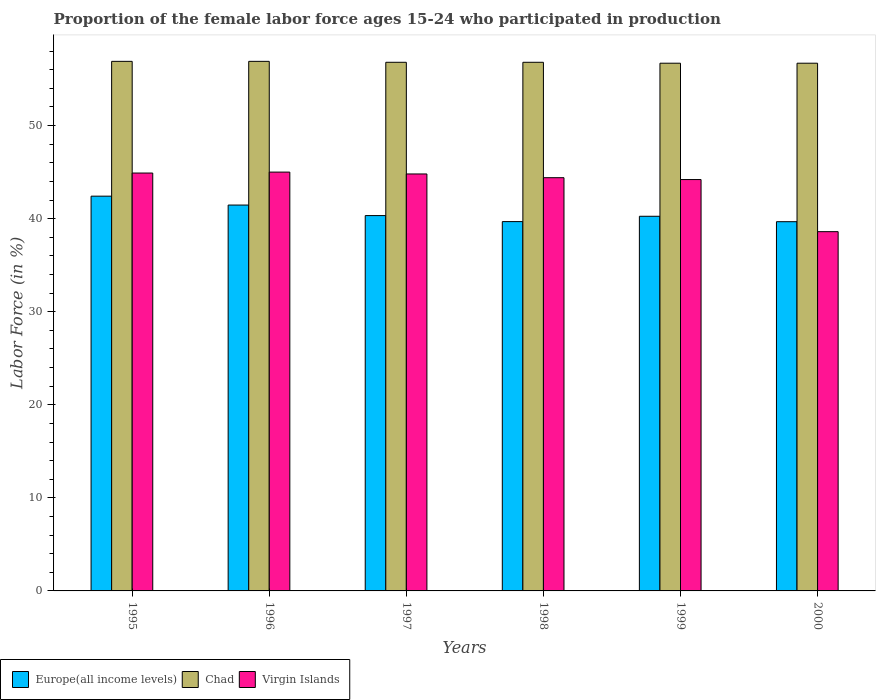How many groups of bars are there?
Provide a short and direct response. 6. Are the number of bars on each tick of the X-axis equal?
Give a very brief answer. Yes. What is the label of the 2nd group of bars from the left?
Your answer should be very brief. 1996. What is the proportion of the female labor force who participated in production in Virgin Islands in 1997?
Give a very brief answer. 44.8. Across all years, what is the maximum proportion of the female labor force who participated in production in Chad?
Your answer should be compact. 56.9. Across all years, what is the minimum proportion of the female labor force who participated in production in Virgin Islands?
Provide a succinct answer. 38.6. In which year was the proportion of the female labor force who participated in production in Virgin Islands minimum?
Keep it short and to the point. 2000. What is the total proportion of the female labor force who participated in production in Europe(all income levels) in the graph?
Provide a succinct answer. 243.81. What is the difference between the proportion of the female labor force who participated in production in Chad in 1997 and that in 1998?
Provide a short and direct response. 0. What is the difference between the proportion of the female labor force who participated in production in Chad in 1997 and the proportion of the female labor force who participated in production in Virgin Islands in 1999?
Provide a short and direct response. 12.6. What is the average proportion of the female labor force who participated in production in Europe(all income levels) per year?
Your response must be concise. 40.64. In the year 1997, what is the difference between the proportion of the female labor force who participated in production in Europe(all income levels) and proportion of the female labor force who participated in production in Chad?
Keep it short and to the point. -16.47. What is the ratio of the proportion of the female labor force who participated in production in Europe(all income levels) in 1995 to that in 1998?
Your response must be concise. 1.07. What is the difference between the highest and the second highest proportion of the female labor force who participated in production in Virgin Islands?
Your answer should be very brief. 0.1. What is the difference between the highest and the lowest proportion of the female labor force who participated in production in Chad?
Give a very brief answer. 0.2. Is the sum of the proportion of the female labor force who participated in production in Europe(all income levels) in 1999 and 2000 greater than the maximum proportion of the female labor force who participated in production in Virgin Islands across all years?
Offer a terse response. Yes. What does the 1st bar from the left in 1996 represents?
Provide a succinct answer. Europe(all income levels). What does the 2nd bar from the right in 1999 represents?
Offer a terse response. Chad. Is it the case that in every year, the sum of the proportion of the female labor force who participated in production in Europe(all income levels) and proportion of the female labor force who participated in production in Chad is greater than the proportion of the female labor force who participated in production in Virgin Islands?
Your answer should be compact. Yes. How many bars are there?
Provide a short and direct response. 18. How many years are there in the graph?
Your response must be concise. 6. What is the difference between two consecutive major ticks on the Y-axis?
Offer a terse response. 10. Are the values on the major ticks of Y-axis written in scientific E-notation?
Offer a very short reply. No. Does the graph contain any zero values?
Offer a terse response. No. Does the graph contain grids?
Offer a very short reply. No. What is the title of the graph?
Offer a very short reply. Proportion of the female labor force ages 15-24 who participated in production. Does "Virgin Islands" appear as one of the legend labels in the graph?
Offer a terse response. Yes. What is the label or title of the Y-axis?
Make the answer very short. Labor Force (in %). What is the Labor Force (in %) of Europe(all income levels) in 1995?
Make the answer very short. 42.41. What is the Labor Force (in %) in Chad in 1995?
Your response must be concise. 56.9. What is the Labor Force (in %) in Virgin Islands in 1995?
Make the answer very short. 44.9. What is the Labor Force (in %) of Europe(all income levels) in 1996?
Offer a very short reply. 41.46. What is the Labor Force (in %) of Chad in 1996?
Provide a short and direct response. 56.9. What is the Labor Force (in %) in Europe(all income levels) in 1997?
Your answer should be very brief. 40.33. What is the Labor Force (in %) in Chad in 1997?
Provide a succinct answer. 56.8. What is the Labor Force (in %) of Virgin Islands in 1997?
Provide a short and direct response. 44.8. What is the Labor Force (in %) of Europe(all income levels) in 1998?
Provide a succinct answer. 39.68. What is the Labor Force (in %) in Chad in 1998?
Provide a short and direct response. 56.8. What is the Labor Force (in %) of Virgin Islands in 1998?
Provide a succinct answer. 44.4. What is the Labor Force (in %) in Europe(all income levels) in 1999?
Your answer should be very brief. 40.25. What is the Labor Force (in %) in Chad in 1999?
Make the answer very short. 56.7. What is the Labor Force (in %) of Virgin Islands in 1999?
Your response must be concise. 44.2. What is the Labor Force (in %) of Europe(all income levels) in 2000?
Provide a succinct answer. 39.67. What is the Labor Force (in %) of Chad in 2000?
Make the answer very short. 56.7. What is the Labor Force (in %) in Virgin Islands in 2000?
Offer a terse response. 38.6. Across all years, what is the maximum Labor Force (in %) in Europe(all income levels)?
Ensure brevity in your answer.  42.41. Across all years, what is the maximum Labor Force (in %) of Chad?
Provide a short and direct response. 56.9. Across all years, what is the minimum Labor Force (in %) in Europe(all income levels)?
Keep it short and to the point. 39.67. Across all years, what is the minimum Labor Force (in %) in Chad?
Give a very brief answer. 56.7. Across all years, what is the minimum Labor Force (in %) in Virgin Islands?
Provide a short and direct response. 38.6. What is the total Labor Force (in %) of Europe(all income levels) in the graph?
Make the answer very short. 243.81. What is the total Labor Force (in %) of Chad in the graph?
Provide a short and direct response. 340.8. What is the total Labor Force (in %) in Virgin Islands in the graph?
Give a very brief answer. 261.9. What is the difference between the Labor Force (in %) in Europe(all income levels) in 1995 and that in 1996?
Give a very brief answer. 0.96. What is the difference between the Labor Force (in %) in Chad in 1995 and that in 1996?
Your response must be concise. 0. What is the difference between the Labor Force (in %) of Europe(all income levels) in 1995 and that in 1997?
Your answer should be very brief. 2.09. What is the difference between the Labor Force (in %) in Chad in 1995 and that in 1997?
Your answer should be very brief. 0.1. What is the difference between the Labor Force (in %) of Europe(all income levels) in 1995 and that in 1998?
Offer a terse response. 2.73. What is the difference between the Labor Force (in %) in Chad in 1995 and that in 1998?
Provide a short and direct response. 0.1. What is the difference between the Labor Force (in %) of Europe(all income levels) in 1995 and that in 1999?
Your answer should be very brief. 2.16. What is the difference between the Labor Force (in %) of Chad in 1995 and that in 1999?
Give a very brief answer. 0.2. What is the difference between the Labor Force (in %) of Europe(all income levels) in 1995 and that in 2000?
Make the answer very short. 2.74. What is the difference between the Labor Force (in %) of Virgin Islands in 1995 and that in 2000?
Offer a very short reply. 6.3. What is the difference between the Labor Force (in %) of Europe(all income levels) in 1996 and that in 1997?
Your answer should be compact. 1.13. What is the difference between the Labor Force (in %) in Virgin Islands in 1996 and that in 1997?
Give a very brief answer. 0.2. What is the difference between the Labor Force (in %) of Europe(all income levels) in 1996 and that in 1998?
Provide a succinct answer. 1.78. What is the difference between the Labor Force (in %) of Europe(all income levels) in 1996 and that in 1999?
Your answer should be very brief. 1.21. What is the difference between the Labor Force (in %) of Chad in 1996 and that in 1999?
Provide a short and direct response. 0.2. What is the difference between the Labor Force (in %) of Europe(all income levels) in 1996 and that in 2000?
Provide a short and direct response. 1.79. What is the difference between the Labor Force (in %) in Virgin Islands in 1996 and that in 2000?
Keep it short and to the point. 6.4. What is the difference between the Labor Force (in %) of Europe(all income levels) in 1997 and that in 1998?
Give a very brief answer. 0.65. What is the difference between the Labor Force (in %) in Europe(all income levels) in 1997 and that in 1999?
Provide a succinct answer. 0.07. What is the difference between the Labor Force (in %) in Virgin Islands in 1997 and that in 1999?
Make the answer very short. 0.6. What is the difference between the Labor Force (in %) in Europe(all income levels) in 1997 and that in 2000?
Offer a very short reply. 0.66. What is the difference between the Labor Force (in %) of Europe(all income levels) in 1998 and that in 1999?
Your answer should be very brief. -0.57. What is the difference between the Labor Force (in %) in Chad in 1998 and that in 1999?
Provide a short and direct response. 0.1. What is the difference between the Labor Force (in %) of Europe(all income levels) in 1998 and that in 2000?
Provide a short and direct response. 0.01. What is the difference between the Labor Force (in %) of Chad in 1998 and that in 2000?
Give a very brief answer. 0.1. What is the difference between the Labor Force (in %) of Europe(all income levels) in 1999 and that in 2000?
Your answer should be compact. 0.58. What is the difference between the Labor Force (in %) of Europe(all income levels) in 1995 and the Labor Force (in %) of Chad in 1996?
Offer a very short reply. -14.49. What is the difference between the Labor Force (in %) of Europe(all income levels) in 1995 and the Labor Force (in %) of Virgin Islands in 1996?
Your answer should be very brief. -2.59. What is the difference between the Labor Force (in %) in Chad in 1995 and the Labor Force (in %) in Virgin Islands in 1996?
Offer a terse response. 11.9. What is the difference between the Labor Force (in %) of Europe(all income levels) in 1995 and the Labor Force (in %) of Chad in 1997?
Ensure brevity in your answer.  -14.39. What is the difference between the Labor Force (in %) of Europe(all income levels) in 1995 and the Labor Force (in %) of Virgin Islands in 1997?
Keep it short and to the point. -2.39. What is the difference between the Labor Force (in %) of Europe(all income levels) in 1995 and the Labor Force (in %) of Chad in 1998?
Your response must be concise. -14.39. What is the difference between the Labor Force (in %) in Europe(all income levels) in 1995 and the Labor Force (in %) in Virgin Islands in 1998?
Offer a very short reply. -1.99. What is the difference between the Labor Force (in %) of Europe(all income levels) in 1995 and the Labor Force (in %) of Chad in 1999?
Give a very brief answer. -14.29. What is the difference between the Labor Force (in %) in Europe(all income levels) in 1995 and the Labor Force (in %) in Virgin Islands in 1999?
Give a very brief answer. -1.79. What is the difference between the Labor Force (in %) in Chad in 1995 and the Labor Force (in %) in Virgin Islands in 1999?
Offer a very short reply. 12.7. What is the difference between the Labor Force (in %) of Europe(all income levels) in 1995 and the Labor Force (in %) of Chad in 2000?
Provide a short and direct response. -14.29. What is the difference between the Labor Force (in %) in Europe(all income levels) in 1995 and the Labor Force (in %) in Virgin Islands in 2000?
Provide a short and direct response. 3.81. What is the difference between the Labor Force (in %) of Europe(all income levels) in 1996 and the Labor Force (in %) of Chad in 1997?
Ensure brevity in your answer.  -15.34. What is the difference between the Labor Force (in %) in Europe(all income levels) in 1996 and the Labor Force (in %) in Virgin Islands in 1997?
Offer a terse response. -3.34. What is the difference between the Labor Force (in %) in Chad in 1996 and the Labor Force (in %) in Virgin Islands in 1997?
Ensure brevity in your answer.  12.1. What is the difference between the Labor Force (in %) of Europe(all income levels) in 1996 and the Labor Force (in %) of Chad in 1998?
Offer a terse response. -15.34. What is the difference between the Labor Force (in %) in Europe(all income levels) in 1996 and the Labor Force (in %) in Virgin Islands in 1998?
Provide a succinct answer. -2.94. What is the difference between the Labor Force (in %) in Europe(all income levels) in 1996 and the Labor Force (in %) in Chad in 1999?
Give a very brief answer. -15.24. What is the difference between the Labor Force (in %) in Europe(all income levels) in 1996 and the Labor Force (in %) in Virgin Islands in 1999?
Provide a short and direct response. -2.74. What is the difference between the Labor Force (in %) in Chad in 1996 and the Labor Force (in %) in Virgin Islands in 1999?
Offer a very short reply. 12.7. What is the difference between the Labor Force (in %) of Europe(all income levels) in 1996 and the Labor Force (in %) of Chad in 2000?
Offer a very short reply. -15.24. What is the difference between the Labor Force (in %) of Europe(all income levels) in 1996 and the Labor Force (in %) of Virgin Islands in 2000?
Make the answer very short. 2.86. What is the difference between the Labor Force (in %) in Europe(all income levels) in 1997 and the Labor Force (in %) in Chad in 1998?
Offer a very short reply. -16.47. What is the difference between the Labor Force (in %) in Europe(all income levels) in 1997 and the Labor Force (in %) in Virgin Islands in 1998?
Make the answer very short. -4.07. What is the difference between the Labor Force (in %) of Europe(all income levels) in 1997 and the Labor Force (in %) of Chad in 1999?
Ensure brevity in your answer.  -16.37. What is the difference between the Labor Force (in %) of Europe(all income levels) in 1997 and the Labor Force (in %) of Virgin Islands in 1999?
Your answer should be compact. -3.87. What is the difference between the Labor Force (in %) in Chad in 1997 and the Labor Force (in %) in Virgin Islands in 1999?
Make the answer very short. 12.6. What is the difference between the Labor Force (in %) of Europe(all income levels) in 1997 and the Labor Force (in %) of Chad in 2000?
Provide a succinct answer. -16.37. What is the difference between the Labor Force (in %) in Europe(all income levels) in 1997 and the Labor Force (in %) in Virgin Islands in 2000?
Your response must be concise. 1.73. What is the difference between the Labor Force (in %) in Chad in 1997 and the Labor Force (in %) in Virgin Islands in 2000?
Offer a very short reply. 18.2. What is the difference between the Labor Force (in %) in Europe(all income levels) in 1998 and the Labor Force (in %) in Chad in 1999?
Your answer should be compact. -17.02. What is the difference between the Labor Force (in %) in Europe(all income levels) in 1998 and the Labor Force (in %) in Virgin Islands in 1999?
Keep it short and to the point. -4.52. What is the difference between the Labor Force (in %) in Europe(all income levels) in 1998 and the Labor Force (in %) in Chad in 2000?
Your answer should be compact. -17.02. What is the difference between the Labor Force (in %) of Europe(all income levels) in 1998 and the Labor Force (in %) of Virgin Islands in 2000?
Give a very brief answer. 1.08. What is the difference between the Labor Force (in %) in Chad in 1998 and the Labor Force (in %) in Virgin Islands in 2000?
Give a very brief answer. 18.2. What is the difference between the Labor Force (in %) in Europe(all income levels) in 1999 and the Labor Force (in %) in Chad in 2000?
Your answer should be very brief. -16.45. What is the difference between the Labor Force (in %) of Europe(all income levels) in 1999 and the Labor Force (in %) of Virgin Islands in 2000?
Ensure brevity in your answer.  1.65. What is the difference between the Labor Force (in %) of Chad in 1999 and the Labor Force (in %) of Virgin Islands in 2000?
Offer a terse response. 18.1. What is the average Labor Force (in %) in Europe(all income levels) per year?
Provide a succinct answer. 40.64. What is the average Labor Force (in %) in Chad per year?
Your answer should be compact. 56.8. What is the average Labor Force (in %) in Virgin Islands per year?
Make the answer very short. 43.65. In the year 1995, what is the difference between the Labor Force (in %) in Europe(all income levels) and Labor Force (in %) in Chad?
Your answer should be very brief. -14.49. In the year 1995, what is the difference between the Labor Force (in %) of Europe(all income levels) and Labor Force (in %) of Virgin Islands?
Offer a terse response. -2.49. In the year 1995, what is the difference between the Labor Force (in %) of Chad and Labor Force (in %) of Virgin Islands?
Offer a terse response. 12. In the year 1996, what is the difference between the Labor Force (in %) in Europe(all income levels) and Labor Force (in %) in Chad?
Your answer should be very brief. -15.44. In the year 1996, what is the difference between the Labor Force (in %) in Europe(all income levels) and Labor Force (in %) in Virgin Islands?
Offer a very short reply. -3.54. In the year 1997, what is the difference between the Labor Force (in %) in Europe(all income levels) and Labor Force (in %) in Chad?
Give a very brief answer. -16.47. In the year 1997, what is the difference between the Labor Force (in %) in Europe(all income levels) and Labor Force (in %) in Virgin Islands?
Keep it short and to the point. -4.47. In the year 1997, what is the difference between the Labor Force (in %) in Chad and Labor Force (in %) in Virgin Islands?
Your answer should be compact. 12. In the year 1998, what is the difference between the Labor Force (in %) of Europe(all income levels) and Labor Force (in %) of Chad?
Offer a terse response. -17.12. In the year 1998, what is the difference between the Labor Force (in %) in Europe(all income levels) and Labor Force (in %) in Virgin Islands?
Ensure brevity in your answer.  -4.72. In the year 1999, what is the difference between the Labor Force (in %) of Europe(all income levels) and Labor Force (in %) of Chad?
Your answer should be compact. -16.45. In the year 1999, what is the difference between the Labor Force (in %) of Europe(all income levels) and Labor Force (in %) of Virgin Islands?
Offer a very short reply. -3.95. In the year 2000, what is the difference between the Labor Force (in %) in Europe(all income levels) and Labor Force (in %) in Chad?
Give a very brief answer. -17.03. In the year 2000, what is the difference between the Labor Force (in %) in Europe(all income levels) and Labor Force (in %) in Virgin Islands?
Make the answer very short. 1.07. In the year 2000, what is the difference between the Labor Force (in %) in Chad and Labor Force (in %) in Virgin Islands?
Offer a terse response. 18.1. What is the ratio of the Labor Force (in %) in Europe(all income levels) in 1995 to that in 1996?
Make the answer very short. 1.02. What is the ratio of the Labor Force (in %) in Chad in 1995 to that in 1996?
Ensure brevity in your answer.  1. What is the ratio of the Labor Force (in %) of Virgin Islands in 1995 to that in 1996?
Your answer should be compact. 1. What is the ratio of the Labor Force (in %) of Europe(all income levels) in 1995 to that in 1997?
Give a very brief answer. 1.05. What is the ratio of the Labor Force (in %) of Chad in 1995 to that in 1997?
Your response must be concise. 1. What is the ratio of the Labor Force (in %) of Europe(all income levels) in 1995 to that in 1998?
Provide a short and direct response. 1.07. What is the ratio of the Labor Force (in %) of Virgin Islands in 1995 to that in 1998?
Your answer should be compact. 1.01. What is the ratio of the Labor Force (in %) in Europe(all income levels) in 1995 to that in 1999?
Make the answer very short. 1.05. What is the ratio of the Labor Force (in %) in Chad in 1995 to that in 1999?
Provide a succinct answer. 1. What is the ratio of the Labor Force (in %) of Virgin Islands in 1995 to that in 1999?
Your answer should be very brief. 1.02. What is the ratio of the Labor Force (in %) in Europe(all income levels) in 1995 to that in 2000?
Your answer should be compact. 1.07. What is the ratio of the Labor Force (in %) of Chad in 1995 to that in 2000?
Your answer should be very brief. 1. What is the ratio of the Labor Force (in %) of Virgin Islands in 1995 to that in 2000?
Offer a terse response. 1.16. What is the ratio of the Labor Force (in %) in Europe(all income levels) in 1996 to that in 1997?
Make the answer very short. 1.03. What is the ratio of the Labor Force (in %) of Chad in 1996 to that in 1997?
Ensure brevity in your answer.  1. What is the ratio of the Labor Force (in %) in Europe(all income levels) in 1996 to that in 1998?
Offer a very short reply. 1.04. What is the ratio of the Labor Force (in %) of Virgin Islands in 1996 to that in 1998?
Your answer should be compact. 1.01. What is the ratio of the Labor Force (in %) in Europe(all income levels) in 1996 to that in 1999?
Make the answer very short. 1.03. What is the ratio of the Labor Force (in %) in Virgin Islands in 1996 to that in 1999?
Your response must be concise. 1.02. What is the ratio of the Labor Force (in %) of Europe(all income levels) in 1996 to that in 2000?
Ensure brevity in your answer.  1.05. What is the ratio of the Labor Force (in %) of Virgin Islands in 1996 to that in 2000?
Give a very brief answer. 1.17. What is the ratio of the Labor Force (in %) of Europe(all income levels) in 1997 to that in 1998?
Make the answer very short. 1.02. What is the ratio of the Labor Force (in %) of Europe(all income levels) in 1997 to that in 1999?
Give a very brief answer. 1. What is the ratio of the Labor Force (in %) in Virgin Islands in 1997 to that in 1999?
Offer a very short reply. 1.01. What is the ratio of the Labor Force (in %) in Europe(all income levels) in 1997 to that in 2000?
Your answer should be compact. 1.02. What is the ratio of the Labor Force (in %) of Chad in 1997 to that in 2000?
Ensure brevity in your answer.  1. What is the ratio of the Labor Force (in %) in Virgin Islands in 1997 to that in 2000?
Offer a very short reply. 1.16. What is the ratio of the Labor Force (in %) in Europe(all income levels) in 1998 to that in 1999?
Provide a succinct answer. 0.99. What is the ratio of the Labor Force (in %) in Europe(all income levels) in 1998 to that in 2000?
Give a very brief answer. 1. What is the ratio of the Labor Force (in %) of Chad in 1998 to that in 2000?
Offer a very short reply. 1. What is the ratio of the Labor Force (in %) of Virgin Islands in 1998 to that in 2000?
Your answer should be very brief. 1.15. What is the ratio of the Labor Force (in %) of Europe(all income levels) in 1999 to that in 2000?
Ensure brevity in your answer.  1.01. What is the ratio of the Labor Force (in %) in Chad in 1999 to that in 2000?
Your answer should be compact. 1. What is the ratio of the Labor Force (in %) of Virgin Islands in 1999 to that in 2000?
Keep it short and to the point. 1.15. What is the difference between the highest and the second highest Labor Force (in %) of Europe(all income levels)?
Your answer should be compact. 0.96. What is the difference between the highest and the second highest Labor Force (in %) of Chad?
Provide a short and direct response. 0. What is the difference between the highest and the second highest Labor Force (in %) of Virgin Islands?
Provide a succinct answer. 0.1. What is the difference between the highest and the lowest Labor Force (in %) in Europe(all income levels)?
Make the answer very short. 2.74. What is the difference between the highest and the lowest Labor Force (in %) of Chad?
Your answer should be very brief. 0.2. 